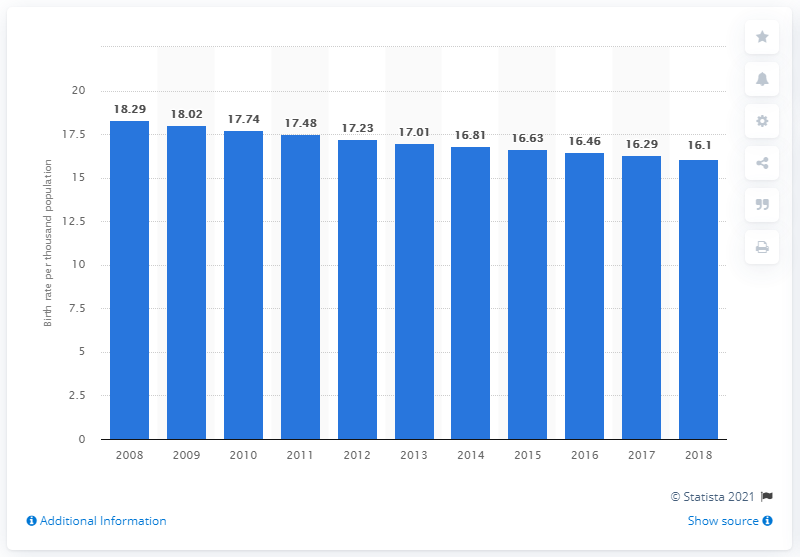Point out several critical features in this image. According to data from 2018, the crude birth rate in Jamaica was 16.1. 